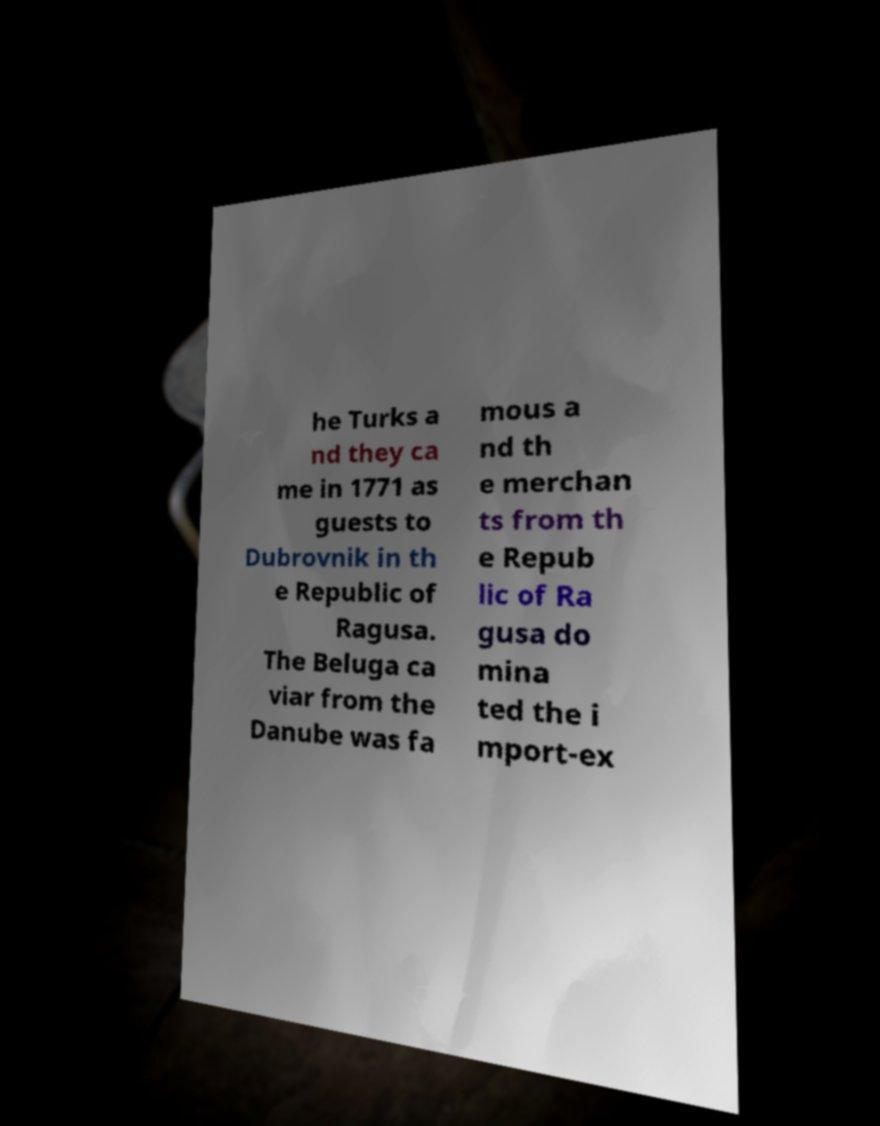There's text embedded in this image that I need extracted. Can you transcribe it verbatim? he Turks a nd they ca me in 1771 as guests to Dubrovnik in th e Republic of Ragusa. The Beluga ca viar from the Danube was fa mous a nd th e merchan ts from th e Repub lic of Ra gusa do mina ted the i mport-ex 